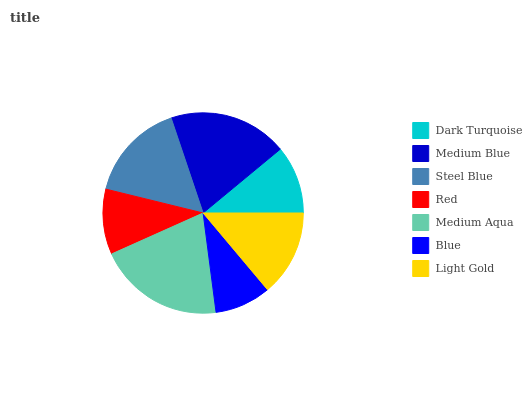Is Blue the minimum?
Answer yes or no. Yes. Is Medium Aqua the maximum?
Answer yes or no. Yes. Is Medium Blue the minimum?
Answer yes or no. No. Is Medium Blue the maximum?
Answer yes or no. No. Is Medium Blue greater than Dark Turquoise?
Answer yes or no. Yes. Is Dark Turquoise less than Medium Blue?
Answer yes or no. Yes. Is Dark Turquoise greater than Medium Blue?
Answer yes or no. No. Is Medium Blue less than Dark Turquoise?
Answer yes or no. No. Is Light Gold the high median?
Answer yes or no. Yes. Is Light Gold the low median?
Answer yes or no. Yes. Is Medium Blue the high median?
Answer yes or no. No. Is Red the low median?
Answer yes or no. No. 